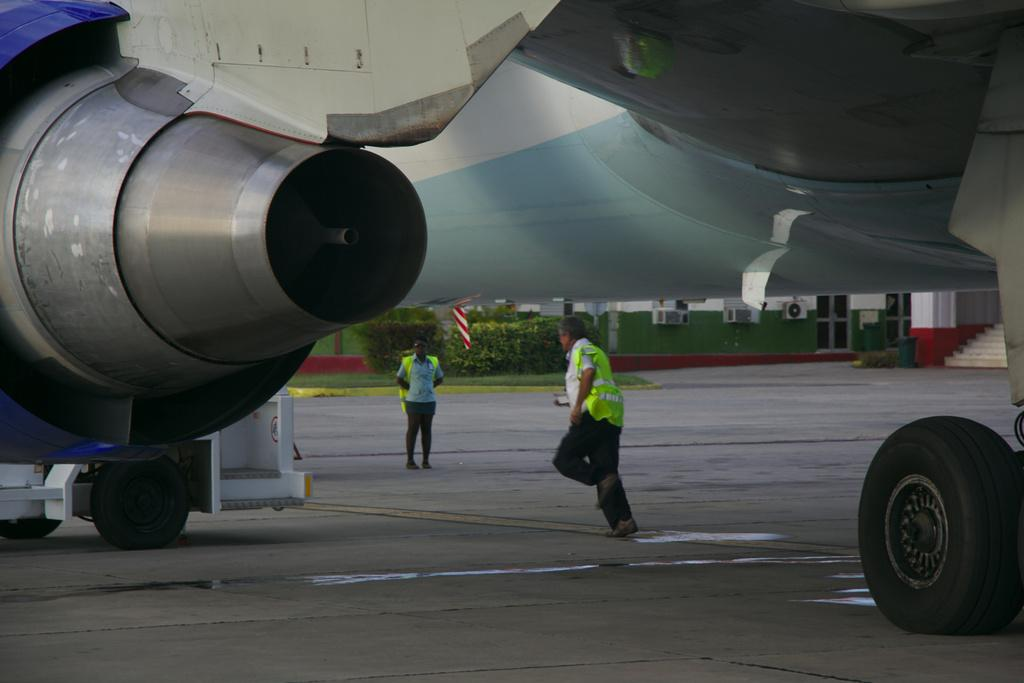What is the unusual object on the road in the image? There is an aircraft on the road in the image. What are the people doing under the aircraft? There are persons on the road under the aircraft. What can be seen in the background of the image? There are plants, grass, and a building in the background of the image. What type of fruit is hanging from the trees in the image? There are no trees present in the image, so no fruit can be seen hanging from them. 